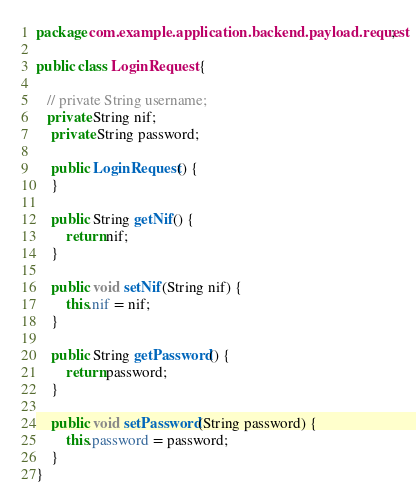Convert code to text. <code><loc_0><loc_0><loc_500><loc_500><_Java_>package com.example.application.backend.payload.request;

public class LoginRequest {

   // private String username;
   private String nif;
    private String password;

    public LoginRequest() {
    }

    public String getNif() {
        return nif;
    }

    public void setNif(String nif) {
        this.nif = nif;
    }

    public String getPassword() {
        return password;
    }

    public void setPassword(String password) {
        this.password = password;
    }
}
</code> 